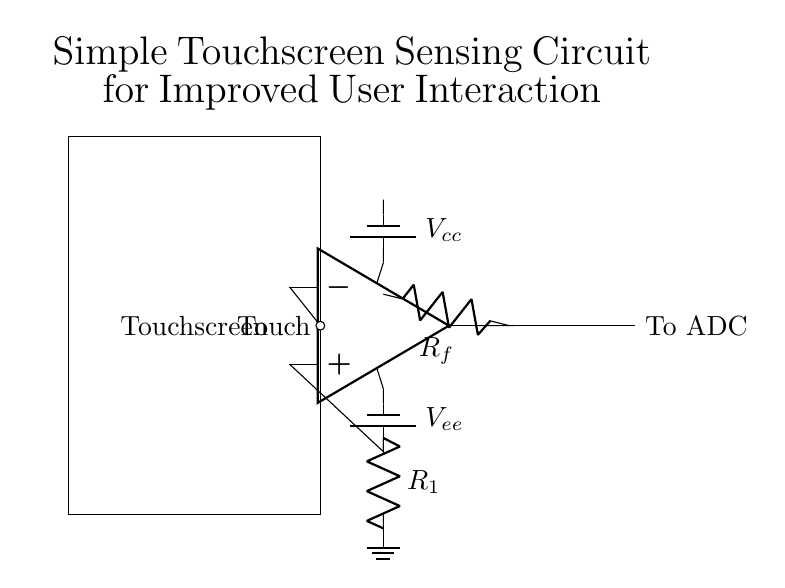What component acts as the input for touch sensing? The input for touch sensing is the op amp's negative terminal, which is connected to the "Touch" node. This node is where the user's touch is detected, allowing the op amp to process the signal.
Answer: Touch What is the output of the op amp? The output of the op amp is directed towards the ADC, indicated by the connection labeled "To ADC." This output is the processed signal that will be converted to a digital format for further interaction.
Answer: To ADC How many resistors are present in this circuit? There are two resistors in the circuit, one labeled R1 and the other labeled Rf. These resistors play a role in adjusting the gain and feedback of the op amp, influencing its response to the touch input.
Answer: 2 What is the role of the Vcc battery? The Vcc battery serves as the positive power supply for the op amp in the circuit. It provides the necessary voltage for the op amp to function correctly and process the incoming touch signals.
Answer: Positive power supply Why is there a battery labeled Vee in the circuit? The Vee battery is labeled as the negative power supply, providing a reference point for the op amp's operation. This dual power supply configuration allows the op amp to accurately process signals from both the positive and negative ranges.
Answer: Negative power supply Which component helps improve user interaction? The touchscreen component is essential for improving user interaction, as it facilitates direct user input by detecting touches and translating them into signals that can be processed by the circuit.
Answer: Touchscreen What does Rf do in this circuit? The resistor Rf is used for feedback in the op amp configuration, which helps to control the gain of the amplifier. This feedback loop adjusts the sensitivity of the circuit in response to touch inputs, enhancing user interaction.
Answer: Gain control 